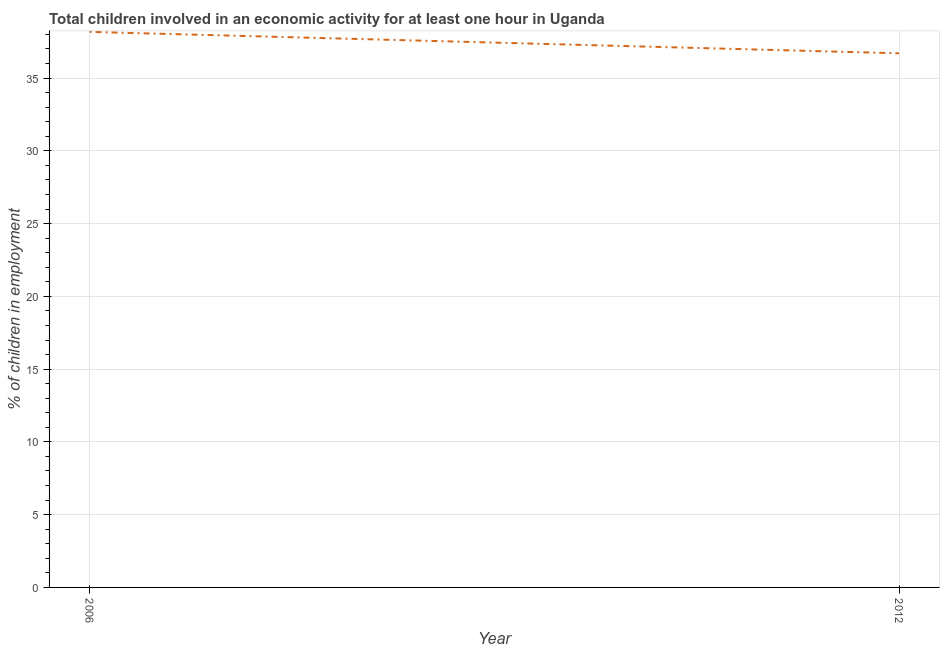What is the percentage of children in employment in 2012?
Your response must be concise. 36.7. Across all years, what is the maximum percentage of children in employment?
Your answer should be compact. 38.17. Across all years, what is the minimum percentage of children in employment?
Keep it short and to the point. 36.7. In which year was the percentage of children in employment minimum?
Offer a very short reply. 2012. What is the sum of the percentage of children in employment?
Your answer should be compact. 74.87. What is the difference between the percentage of children in employment in 2006 and 2012?
Provide a short and direct response. 1.47. What is the average percentage of children in employment per year?
Offer a terse response. 37.44. What is the median percentage of children in employment?
Give a very brief answer. 37.44. Do a majority of the years between 2006 and 2012 (inclusive) have percentage of children in employment greater than 34 %?
Your answer should be very brief. Yes. What is the ratio of the percentage of children in employment in 2006 to that in 2012?
Offer a very short reply. 1.04. Is the percentage of children in employment in 2006 less than that in 2012?
Keep it short and to the point. No. Does the percentage of children in employment monotonically increase over the years?
Offer a very short reply. No. How many lines are there?
Provide a short and direct response. 1. How many years are there in the graph?
Provide a short and direct response. 2. What is the title of the graph?
Offer a terse response. Total children involved in an economic activity for at least one hour in Uganda. What is the label or title of the X-axis?
Provide a short and direct response. Year. What is the label or title of the Y-axis?
Keep it short and to the point. % of children in employment. What is the % of children in employment in 2006?
Offer a terse response. 38.17. What is the % of children in employment of 2012?
Keep it short and to the point. 36.7. What is the difference between the % of children in employment in 2006 and 2012?
Offer a very short reply. 1.47. 